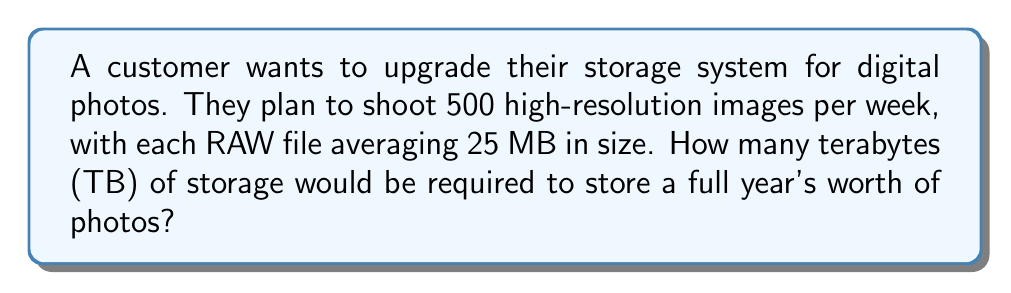Give your solution to this math problem. Let's break this down step-by-step:

1. Calculate the number of photos taken in a year:
   $$ \text{Photos per year} = 500 \text{ photos/week} \times 52 \text{ weeks} = 26,000 \text{ photos} $$

2. Calculate the total storage needed in megabytes (MB):
   $$ \text{Total MB} = 26,000 \text{ photos} \times 25 \text{ MB/photo} = 650,000 \text{ MB} $$

3. Convert MB to GB:
   $$ \text{Total GB} = \frac{650,000 \text{ MB}}{1024 \text{ MB/GB}} \approx 634.77 \text{ GB} $$

4. Convert GB to TB:
   $$ \text{Total TB} = \frac{634.77 \text{ GB}}{1024 \text{ GB/TB}} \approx 0.62 \text{ TB} $$

Therefore, the customer would need approximately 0.62 TB of storage for a full year's worth of photos.
Answer: 0.62 TB 